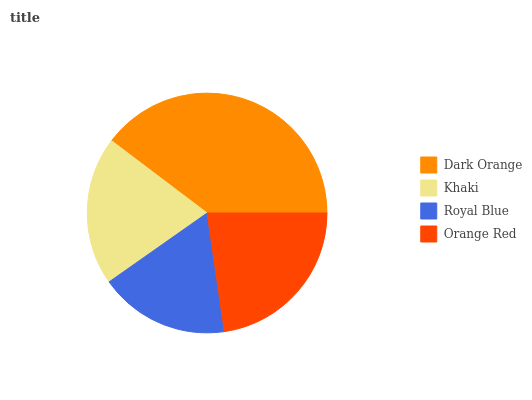Is Royal Blue the minimum?
Answer yes or no. Yes. Is Dark Orange the maximum?
Answer yes or no. Yes. Is Khaki the minimum?
Answer yes or no. No. Is Khaki the maximum?
Answer yes or no. No. Is Dark Orange greater than Khaki?
Answer yes or no. Yes. Is Khaki less than Dark Orange?
Answer yes or no. Yes. Is Khaki greater than Dark Orange?
Answer yes or no. No. Is Dark Orange less than Khaki?
Answer yes or no. No. Is Orange Red the high median?
Answer yes or no. Yes. Is Khaki the low median?
Answer yes or no. Yes. Is Khaki the high median?
Answer yes or no. No. Is Dark Orange the low median?
Answer yes or no. No. 